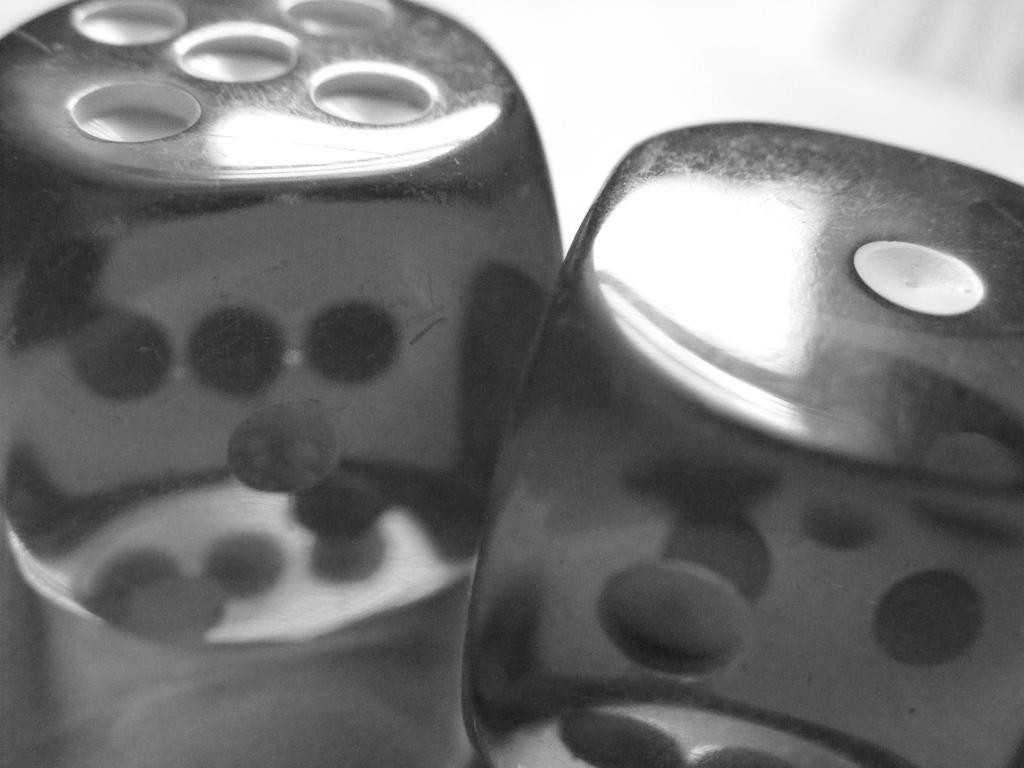In one or two sentences, can you explain what this image depicts? It is a black and white image. In this image we can see the two dice on the surface. 